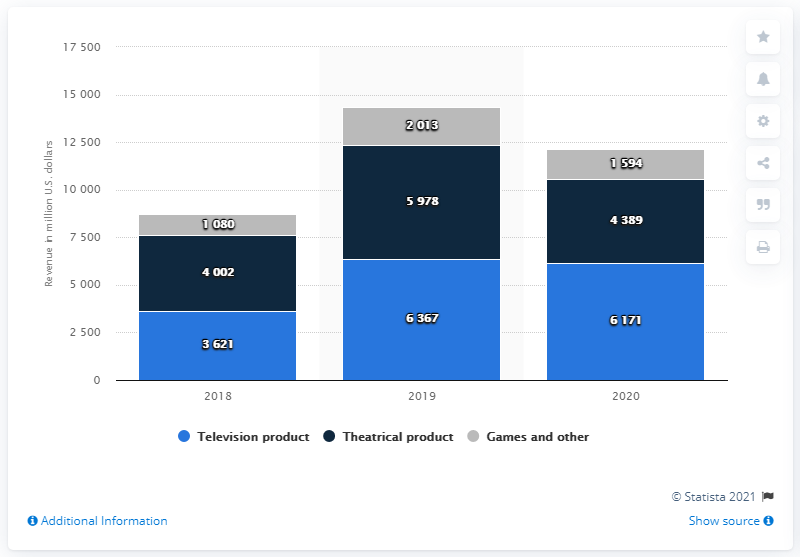Draw attention to some important aspects in this diagram. In 2019, the most popular product was the television product. In 2019, the combined revenue from television and theatrical products was 12345. Warner Bros.'s consumer product revenue derived 4389% from theatrical product. 